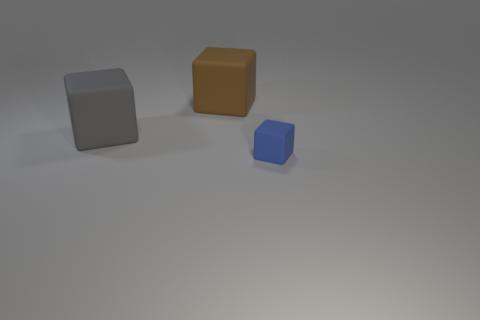Is there anything else that has the same size as the blue cube?
Offer a terse response. No. Do the gray matte object and the matte object in front of the gray thing have the same shape?
Provide a succinct answer. Yes. There is a large cube that is in front of the big matte block that is behind the big block left of the brown matte block; what is its color?
Your response must be concise. Gray. What number of objects are either matte blocks that are left of the blue block or matte blocks that are behind the blue rubber thing?
Keep it short and to the point. 2. There is a big matte object behind the gray matte object; does it have the same shape as the blue matte object?
Keep it short and to the point. Yes. Are there fewer big brown rubber objects to the left of the large gray rubber cube than big blue cubes?
Give a very brief answer. No. Are there any large gray cubes that have the same material as the tiny blue cube?
Offer a very short reply. Yes. What material is the other block that is the same size as the gray block?
Provide a succinct answer. Rubber. Is the number of big brown objects to the left of the brown rubber block less than the number of blue blocks behind the big gray rubber block?
Keep it short and to the point. No. What shape is the rubber thing that is both in front of the brown rubber cube and to the right of the big gray cube?
Make the answer very short. Cube. 